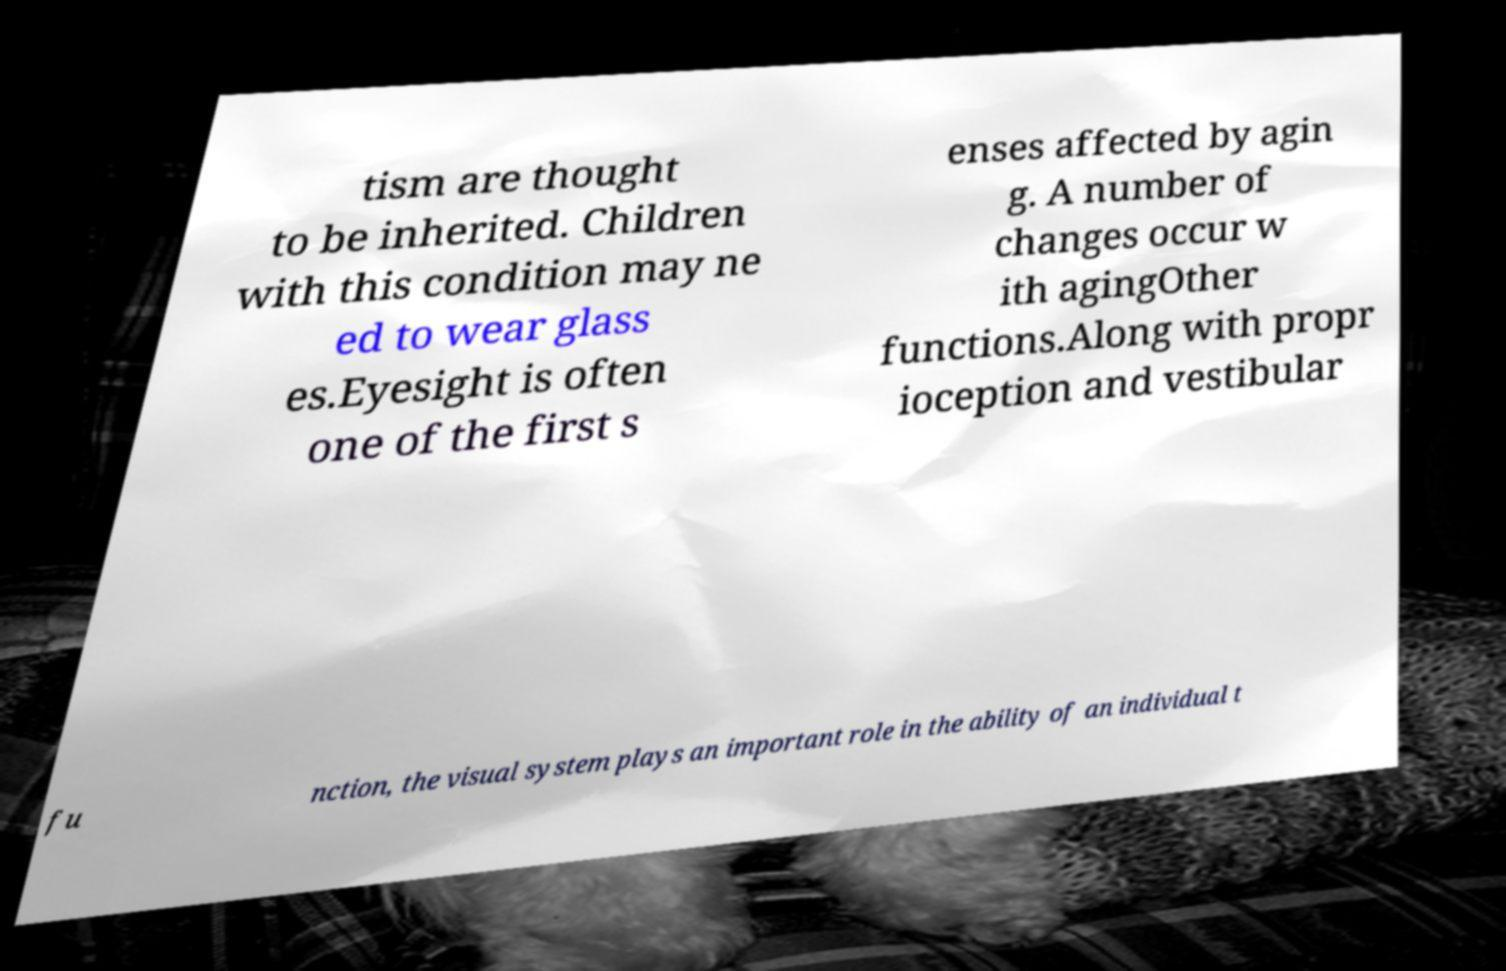Could you extract and type out the text from this image? tism are thought to be inherited. Children with this condition may ne ed to wear glass es.Eyesight is often one of the first s enses affected by agin g. A number of changes occur w ith agingOther functions.Along with propr ioception and vestibular fu nction, the visual system plays an important role in the ability of an individual t 